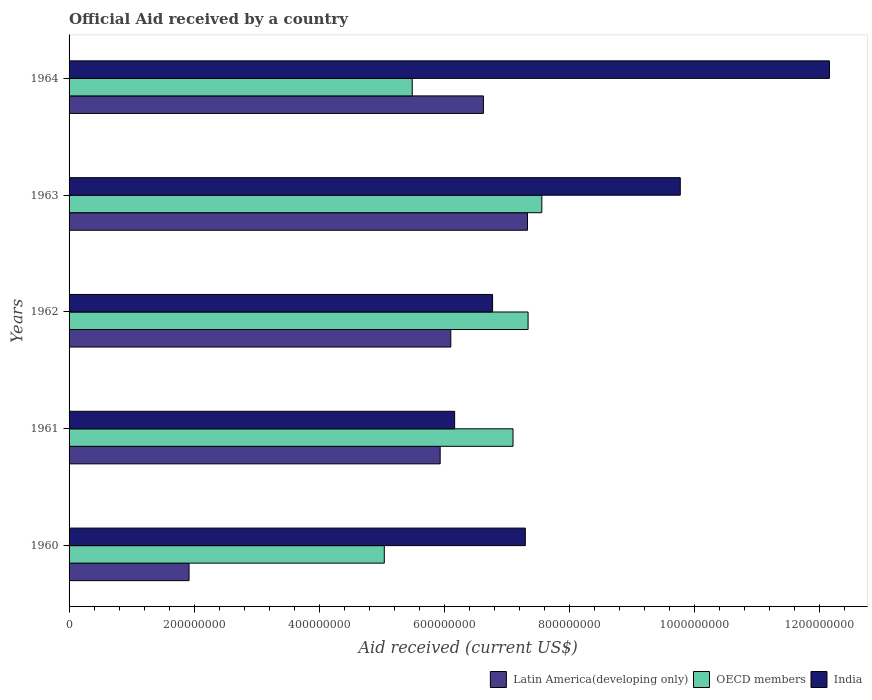How many different coloured bars are there?
Your response must be concise. 3. How many groups of bars are there?
Your answer should be compact. 5. How many bars are there on the 5th tick from the bottom?
Your response must be concise. 3. What is the label of the 2nd group of bars from the top?
Provide a succinct answer. 1963. In how many cases, is the number of bars for a given year not equal to the number of legend labels?
Offer a terse response. 0. What is the net official aid received in India in 1960?
Provide a short and direct response. 7.30e+08. Across all years, what is the maximum net official aid received in OECD members?
Make the answer very short. 7.56e+08. Across all years, what is the minimum net official aid received in Latin America(developing only)?
Provide a succinct answer. 1.92e+08. In which year was the net official aid received in India maximum?
Your answer should be compact. 1964. In which year was the net official aid received in Latin America(developing only) minimum?
Your answer should be very brief. 1960. What is the total net official aid received in Latin America(developing only) in the graph?
Keep it short and to the point. 2.79e+09. What is the difference between the net official aid received in Latin America(developing only) in 1960 and that in 1961?
Offer a very short reply. -4.02e+08. What is the difference between the net official aid received in India in 1962 and the net official aid received in OECD members in 1961?
Your response must be concise. -3.27e+07. What is the average net official aid received in India per year?
Provide a short and direct response. 8.43e+08. In the year 1963, what is the difference between the net official aid received in OECD members and net official aid received in India?
Ensure brevity in your answer.  -2.21e+08. What is the ratio of the net official aid received in OECD members in 1960 to that in 1962?
Give a very brief answer. 0.69. Is the net official aid received in OECD members in 1960 less than that in 1964?
Offer a terse response. Yes. Is the difference between the net official aid received in OECD members in 1962 and 1963 greater than the difference between the net official aid received in India in 1962 and 1963?
Provide a succinct answer. Yes. What is the difference between the highest and the second highest net official aid received in India?
Your response must be concise. 2.39e+08. What is the difference between the highest and the lowest net official aid received in Latin America(developing only)?
Provide a short and direct response. 5.41e+08. Is the sum of the net official aid received in OECD members in 1960 and 1962 greater than the maximum net official aid received in Latin America(developing only) across all years?
Keep it short and to the point. Yes. What does the 3rd bar from the bottom in 1963 represents?
Provide a short and direct response. India. How many bars are there?
Make the answer very short. 15. Are the values on the major ticks of X-axis written in scientific E-notation?
Offer a very short reply. No. Does the graph contain any zero values?
Your answer should be very brief. No. How many legend labels are there?
Offer a very short reply. 3. What is the title of the graph?
Keep it short and to the point. Official Aid received by a country. Does "Least developed countries" appear as one of the legend labels in the graph?
Keep it short and to the point. No. What is the label or title of the X-axis?
Make the answer very short. Aid received (current US$). What is the label or title of the Y-axis?
Keep it short and to the point. Years. What is the Aid received (current US$) of Latin America(developing only) in 1960?
Make the answer very short. 1.92e+08. What is the Aid received (current US$) in OECD members in 1960?
Your response must be concise. 5.04e+08. What is the Aid received (current US$) of India in 1960?
Your answer should be very brief. 7.30e+08. What is the Aid received (current US$) in Latin America(developing only) in 1961?
Your answer should be compact. 5.93e+08. What is the Aid received (current US$) in OECD members in 1961?
Offer a terse response. 7.10e+08. What is the Aid received (current US$) of India in 1961?
Ensure brevity in your answer.  6.17e+08. What is the Aid received (current US$) of Latin America(developing only) in 1962?
Your answer should be compact. 6.10e+08. What is the Aid received (current US$) of OECD members in 1962?
Your answer should be compact. 7.34e+08. What is the Aid received (current US$) in India in 1962?
Give a very brief answer. 6.77e+08. What is the Aid received (current US$) in Latin America(developing only) in 1963?
Offer a very short reply. 7.33e+08. What is the Aid received (current US$) of OECD members in 1963?
Your answer should be very brief. 7.56e+08. What is the Aid received (current US$) of India in 1963?
Your answer should be compact. 9.77e+08. What is the Aid received (current US$) in Latin America(developing only) in 1964?
Your response must be concise. 6.63e+08. What is the Aid received (current US$) of OECD members in 1964?
Keep it short and to the point. 5.49e+08. What is the Aid received (current US$) of India in 1964?
Keep it short and to the point. 1.22e+09. Across all years, what is the maximum Aid received (current US$) in Latin America(developing only)?
Your answer should be compact. 7.33e+08. Across all years, what is the maximum Aid received (current US$) of OECD members?
Make the answer very short. 7.56e+08. Across all years, what is the maximum Aid received (current US$) of India?
Your answer should be compact. 1.22e+09. Across all years, what is the minimum Aid received (current US$) of Latin America(developing only)?
Offer a very short reply. 1.92e+08. Across all years, what is the minimum Aid received (current US$) in OECD members?
Your answer should be very brief. 5.04e+08. Across all years, what is the minimum Aid received (current US$) in India?
Your response must be concise. 6.17e+08. What is the total Aid received (current US$) of Latin America(developing only) in the graph?
Provide a succinct answer. 2.79e+09. What is the total Aid received (current US$) in OECD members in the graph?
Give a very brief answer. 3.25e+09. What is the total Aid received (current US$) in India in the graph?
Provide a succinct answer. 4.22e+09. What is the difference between the Aid received (current US$) of Latin America(developing only) in 1960 and that in 1961?
Provide a succinct answer. -4.02e+08. What is the difference between the Aid received (current US$) in OECD members in 1960 and that in 1961?
Provide a succinct answer. -2.06e+08. What is the difference between the Aid received (current US$) of India in 1960 and that in 1961?
Ensure brevity in your answer.  1.13e+08. What is the difference between the Aid received (current US$) in Latin America(developing only) in 1960 and that in 1962?
Offer a very short reply. -4.19e+08. What is the difference between the Aid received (current US$) of OECD members in 1960 and that in 1962?
Provide a succinct answer. -2.30e+08. What is the difference between the Aid received (current US$) in India in 1960 and that in 1962?
Offer a very short reply. 5.24e+07. What is the difference between the Aid received (current US$) in Latin America(developing only) in 1960 and that in 1963?
Provide a succinct answer. -5.41e+08. What is the difference between the Aid received (current US$) of OECD members in 1960 and that in 1963?
Your response must be concise. -2.52e+08. What is the difference between the Aid received (current US$) of India in 1960 and that in 1963?
Ensure brevity in your answer.  -2.48e+08. What is the difference between the Aid received (current US$) of Latin America(developing only) in 1960 and that in 1964?
Make the answer very short. -4.71e+08. What is the difference between the Aid received (current US$) of OECD members in 1960 and that in 1964?
Offer a very short reply. -4.47e+07. What is the difference between the Aid received (current US$) of India in 1960 and that in 1964?
Your response must be concise. -4.86e+08. What is the difference between the Aid received (current US$) of Latin America(developing only) in 1961 and that in 1962?
Offer a terse response. -1.70e+07. What is the difference between the Aid received (current US$) of OECD members in 1961 and that in 1962?
Ensure brevity in your answer.  -2.41e+07. What is the difference between the Aid received (current US$) of India in 1961 and that in 1962?
Offer a very short reply. -6.07e+07. What is the difference between the Aid received (current US$) of Latin America(developing only) in 1961 and that in 1963?
Make the answer very short. -1.40e+08. What is the difference between the Aid received (current US$) in OECD members in 1961 and that in 1963?
Make the answer very short. -4.61e+07. What is the difference between the Aid received (current US$) of India in 1961 and that in 1963?
Give a very brief answer. -3.61e+08. What is the difference between the Aid received (current US$) in Latin America(developing only) in 1961 and that in 1964?
Provide a short and direct response. -6.92e+07. What is the difference between the Aid received (current US$) of OECD members in 1961 and that in 1964?
Your answer should be compact. 1.61e+08. What is the difference between the Aid received (current US$) in India in 1961 and that in 1964?
Offer a terse response. -5.99e+08. What is the difference between the Aid received (current US$) of Latin America(developing only) in 1962 and that in 1963?
Your answer should be very brief. -1.23e+08. What is the difference between the Aid received (current US$) of OECD members in 1962 and that in 1963?
Offer a terse response. -2.20e+07. What is the difference between the Aid received (current US$) of India in 1962 and that in 1963?
Offer a terse response. -3.00e+08. What is the difference between the Aid received (current US$) of Latin America(developing only) in 1962 and that in 1964?
Ensure brevity in your answer.  -5.22e+07. What is the difference between the Aid received (current US$) of OECD members in 1962 and that in 1964?
Provide a succinct answer. 1.85e+08. What is the difference between the Aid received (current US$) of India in 1962 and that in 1964?
Provide a succinct answer. -5.39e+08. What is the difference between the Aid received (current US$) in Latin America(developing only) in 1963 and that in 1964?
Your answer should be very brief. 7.05e+07. What is the difference between the Aid received (current US$) of OECD members in 1963 and that in 1964?
Your response must be concise. 2.07e+08. What is the difference between the Aid received (current US$) in India in 1963 and that in 1964?
Provide a short and direct response. -2.39e+08. What is the difference between the Aid received (current US$) of Latin America(developing only) in 1960 and the Aid received (current US$) of OECD members in 1961?
Your answer should be very brief. -5.18e+08. What is the difference between the Aid received (current US$) of Latin America(developing only) in 1960 and the Aid received (current US$) of India in 1961?
Give a very brief answer. -4.25e+08. What is the difference between the Aid received (current US$) of OECD members in 1960 and the Aid received (current US$) of India in 1961?
Your response must be concise. -1.12e+08. What is the difference between the Aid received (current US$) in Latin America(developing only) in 1960 and the Aid received (current US$) in OECD members in 1962?
Provide a short and direct response. -5.42e+08. What is the difference between the Aid received (current US$) of Latin America(developing only) in 1960 and the Aid received (current US$) of India in 1962?
Provide a succinct answer. -4.85e+08. What is the difference between the Aid received (current US$) of OECD members in 1960 and the Aid received (current US$) of India in 1962?
Your answer should be very brief. -1.73e+08. What is the difference between the Aid received (current US$) of Latin America(developing only) in 1960 and the Aid received (current US$) of OECD members in 1963?
Your answer should be very brief. -5.64e+08. What is the difference between the Aid received (current US$) in Latin America(developing only) in 1960 and the Aid received (current US$) in India in 1963?
Your answer should be compact. -7.86e+08. What is the difference between the Aid received (current US$) of OECD members in 1960 and the Aid received (current US$) of India in 1963?
Offer a terse response. -4.73e+08. What is the difference between the Aid received (current US$) in Latin America(developing only) in 1960 and the Aid received (current US$) in OECD members in 1964?
Give a very brief answer. -3.57e+08. What is the difference between the Aid received (current US$) of Latin America(developing only) in 1960 and the Aid received (current US$) of India in 1964?
Ensure brevity in your answer.  -1.02e+09. What is the difference between the Aid received (current US$) in OECD members in 1960 and the Aid received (current US$) in India in 1964?
Ensure brevity in your answer.  -7.12e+08. What is the difference between the Aid received (current US$) in Latin America(developing only) in 1961 and the Aid received (current US$) in OECD members in 1962?
Offer a very short reply. -1.41e+08. What is the difference between the Aid received (current US$) in Latin America(developing only) in 1961 and the Aid received (current US$) in India in 1962?
Ensure brevity in your answer.  -8.38e+07. What is the difference between the Aid received (current US$) of OECD members in 1961 and the Aid received (current US$) of India in 1962?
Provide a succinct answer. 3.27e+07. What is the difference between the Aid received (current US$) of Latin America(developing only) in 1961 and the Aid received (current US$) of OECD members in 1963?
Provide a succinct answer. -1.63e+08. What is the difference between the Aid received (current US$) in Latin America(developing only) in 1961 and the Aid received (current US$) in India in 1963?
Offer a very short reply. -3.84e+08. What is the difference between the Aid received (current US$) in OECD members in 1961 and the Aid received (current US$) in India in 1963?
Keep it short and to the point. -2.68e+08. What is the difference between the Aid received (current US$) in Latin America(developing only) in 1961 and the Aid received (current US$) in OECD members in 1964?
Your answer should be very brief. 4.47e+07. What is the difference between the Aid received (current US$) in Latin America(developing only) in 1961 and the Aid received (current US$) in India in 1964?
Keep it short and to the point. -6.23e+08. What is the difference between the Aid received (current US$) of OECD members in 1961 and the Aid received (current US$) of India in 1964?
Keep it short and to the point. -5.06e+08. What is the difference between the Aid received (current US$) of Latin America(developing only) in 1962 and the Aid received (current US$) of OECD members in 1963?
Your answer should be very brief. -1.46e+08. What is the difference between the Aid received (current US$) of Latin America(developing only) in 1962 and the Aid received (current US$) of India in 1963?
Your response must be concise. -3.67e+08. What is the difference between the Aid received (current US$) of OECD members in 1962 and the Aid received (current US$) of India in 1963?
Make the answer very short. -2.43e+08. What is the difference between the Aid received (current US$) in Latin America(developing only) in 1962 and the Aid received (current US$) in OECD members in 1964?
Make the answer very short. 6.17e+07. What is the difference between the Aid received (current US$) of Latin America(developing only) in 1962 and the Aid received (current US$) of India in 1964?
Your response must be concise. -6.06e+08. What is the difference between the Aid received (current US$) of OECD members in 1962 and the Aid received (current US$) of India in 1964?
Make the answer very short. -4.82e+08. What is the difference between the Aid received (current US$) of Latin America(developing only) in 1963 and the Aid received (current US$) of OECD members in 1964?
Offer a terse response. 1.84e+08. What is the difference between the Aid received (current US$) in Latin America(developing only) in 1963 and the Aid received (current US$) in India in 1964?
Your answer should be compact. -4.83e+08. What is the difference between the Aid received (current US$) in OECD members in 1963 and the Aid received (current US$) in India in 1964?
Give a very brief answer. -4.60e+08. What is the average Aid received (current US$) in Latin America(developing only) per year?
Your response must be concise. 5.58e+08. What is the average Aid received (current US$) in OECD members per year?
Offer a very short reply. 6.51e+08. What is the average Aid received (current US$) of India per year?
Ensure brevity in your answer.  8.43e+08. In the year 1960, what is the difference between the Aid received (current US$) of Latin America(developing only) and Aid received (current US$) of OECD members?
Provide a short and direct response. -3.12e+08. In the year 1960, what is the difference between the Aid received (current US$) in Latin America(developing only) and Aid received (current US$) in India?
Offer a terse response. -5.38e+08. In the year 1960, what is the difference between the Aid received (current US$) in OECD members and Aid received (current US$) in India?
Provide a succinct answer. -2.26e+08. In the year 1961, what is the difference between the Aid received (current US$) of Latin America(developing only) and Aid received (current US$) of OECD members?
Your response must be concise. -1.16e+08. In the year 1961, what is the difference between the Aid received (current US$) in Latin America(developing only) and Aid received (current US$) in India?
Offer a terse response. -2.31e+07. In the year 1961, what is the difference between the Aid received (current US$) in OECD members and Aid received (current US$) in India?
Offer a terse response. 9.34e+07. In the year 1962, what is the difference between the Aid received (current US$) in Latin America(developing only) and Aid received (current US$) in OECD members?
Offer a very short reply. -1.24e+08. In the year 1962, what is the difference between the Aid received (current US$) of Latin America(developing only) and Aid received (current US$) of India?
Make the answer very short. -6.68e+07. In the year 1962, what is the difference between the Aid received (current US$) of OECD members and Aid received (current US$) of India?
Ensure brevity in your answer.  5.68e+07. In the year 1963, what is the difference between the Aid received (current US$) of Latin America(developing only) and Aid received (current US$) of OECD members?
Your answer should be compact. -2.29e+07. In the year 1963, what is the difference between the Aid received (current US$) of Latin America(developing only) and Aid received (current US$) of India?
Provide a short and direct response. -2.44e+08. In the year 1963, what is the difference between the Aid received (current US$) of OECD members and Aid received (current US$) of India?
Provide a short and direct response. -2.21e+08. In the year 1964, what is the difference between the Aid received (current US$) in Latin America(developing only) and Aid received (current US$) in OECD members?
Give a very brief answer. 1.14e+08. In the year 1964, what is the difference between the Aid received (current US$) in Latin America(developing only) and Aid received (current US$) in India?
Provide a succinct answer. -5.53e+08. In the year 1964, what is the difference between the Aid received (current US$) of OECD members and Aid received (current US$) of India?
Your answer should be very brief. -6.67e+08. What is the ratio of the Aid received (current US$) of Latin America(developing only) in 1960 to that in 1961?
Keep it short and to the point. 0.32. What is the ratio of the Aid received (current US$) of OECD members in 1960 to that in 1961?
Your response must be concise. 0.71. What is the ratio of the Aid received (current US$) in India in 1960 to that in 1961?
Your response must be concise. 1.18. What is the ratio of the Aid received (current US$) in Latin America(developing only) in 1960 to that in 1962?
Keep it short and to the point. 0.31. What is the ratio of the Aid received (current US$) in OECD members in 1960 to that in 1962?
Ensure brevity in your answer.  0.69. What is the ratio of the Aid received (current US$) of India in 1960 to that in 1962?
Your answer should be compact. 1.08. What is the ratio of the Aid received (current US$) of Latin America(developing only) in 1960 to that in 1963?
Your answer should be compact. 0.26. What is the ratio of the Aid received (current US$) in OECD members in 1960 to that in 1963?
Keep it short and to the point. 0.67. What is the ratio of the Aid received (current US$) in India in 1960 to that in 1963?
Your response must be concise. 0.75. What is the ratio of the Aid received (current US$) in Latin America(developing only) in 1960 to that in 1964?
Make the answer very short. 0.29. What is the ratio of the Aid received (current US$) in OECD members in 1960 to that in 1964?
Make the answer very short. 0.92. What is the ratio of the Aid received (current US$) in India in 1960 to that in 1964?
Your answer should be very brief. 0.6. What is the ratio of the Aid received (current US$) of Latin America(developing only) in 1961 to that in 1962?
Provide a short and direct response. 0.97. What is the ratio of the Aid received (current US$) in OECD members in 1961 to that in 1962?
Give a very brief answer. 0.97. What is the ratio of the Aid received (current US$) of India in 1961 to that in 1962?
Your response must be concise. 0.91. What is the ratio of the Aid received (current US$) in Latin America(developing only) in 1961 to that in 1963?
Ensure brevity in your answer.  0.81. What is the ratio of the Aid received (current US$) in OECD members in 1961 to that in 1963?
Provide a succinct answer. 0.94. What is the ratio of the Aid received (current US$) of India in 1961 to that in 1963?
Ensure brevity in your answer.  0.63. What is the ratio of the Aid received (current US$) of Latin America(developing only) in 1961 to that in 1964?
Ensure brevity in your answer.  0.9. What is the ratio of the Aid received (current US$) in OECD members in 1961 to that in 1964?
Your response must be concise. 1.29. What is the ratio of the Aid received (current US$) in India in 1961 to that in 1964?
Your answer should be compact. 0.51. What is the ratio of the Aid received (current US$) of Latin America(developing only) in 1962 to that in 1963?
Ensure brevity in your answer.  0.83. What is the ratio of the Aid received (current US$) of OECD members in 1962 to that in 1963?
Provide a short and direct response. 0.97. What is the ratio of the Aid received (current US$) in India in 1962 to that in 1963?
Your response must be concise. 0.69. What is the ratio of the Aid received (current US$) in Latin America(developing only) in 1962 to that in 1964?
Offer a terse response. 0.92. What is the ratio of the Aid received (current US$) in OECD members in 1962 to that in 1964?
Your answer should be very brief. 1.34. What is the ratio of the Aid received (current US$) in India in 1962 to that in 1964?
Ensure brevity in your answer.  0.56. What is the ratio of the Aid received (current US$) of Latin America(developing only) in 1963 to that in 1964?
Give a very brief answer. 1.11. What is the ratio of the Aid received (current US$) of OECD members in 1963 to that in 1964?
Keep it short and to the point. 1.38. What is the ratio of the Aid received (current US$) in India in 1963 to that in 1964?
Keep it short and to the point. 0.8. What is the difference between the highest and the second highest Aid received (current US$) in Latin America(developing only)?
Ensure brevity in your answer.  7.05e+07. What is the difference between the highest and the second highest Aid received (current US$) of OECD members?
Keep it short and to the point. 2.20e+07. What is the difference between the highest and the second highest Aid received (current US$) in India?
Ensure brevity in your answer.  2.39e+08. What is the difference between the highest and the lowest Aid received (current US$) in Latin America(developing only)?
Offer a terse response. 5.41e+08. What is the difference between the highest and the lowest Aid received (current US$) in OECD members?
Offer a very short reply. 2.52e+08. What is the difference between the highest and the lowest Aid received (current US$) in India?
Provide a succinct answer. 5.99e+08. 